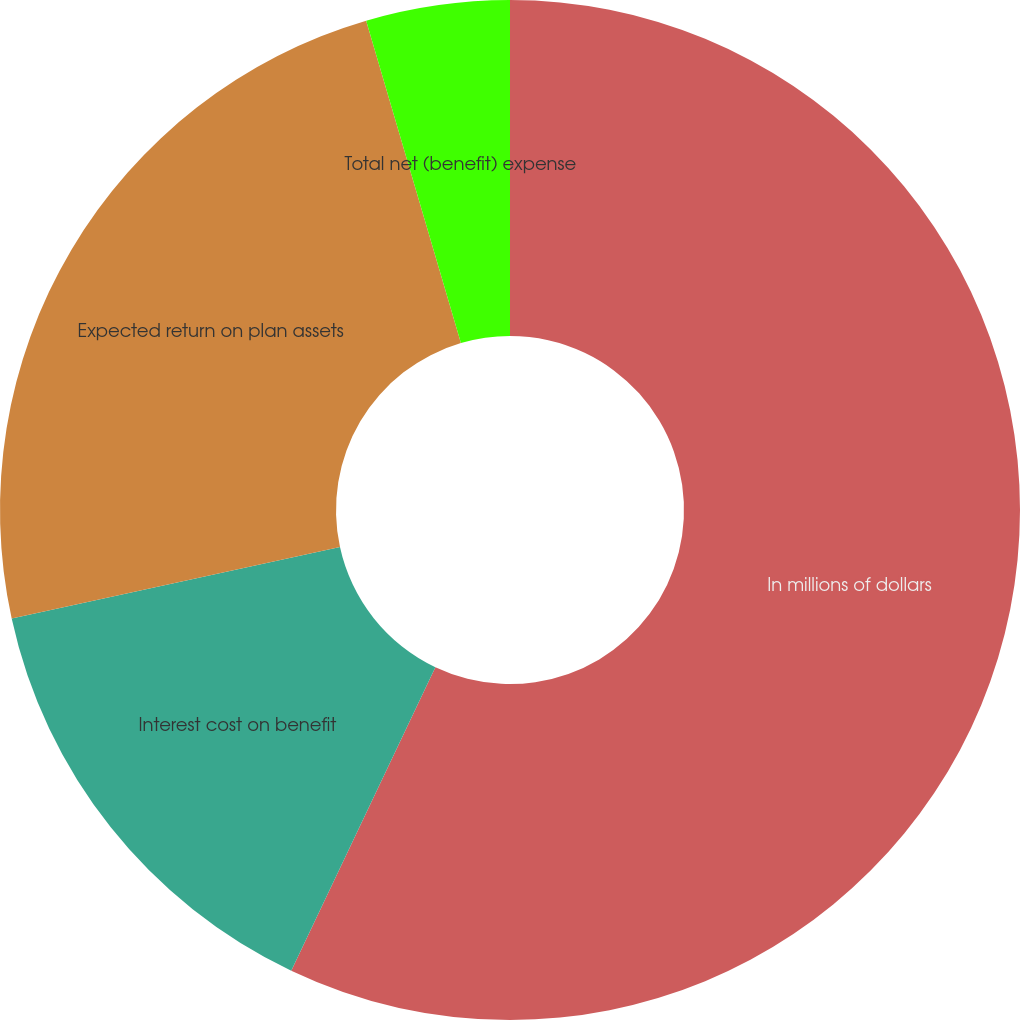Convert chart to OTSL. <chart><loc_0><loc_0><loc_500><loc_500><pie_chart><fcel>In millions of dollars<fcel>Interest cost on benefit<fcel>Expected return on plan assets<fcel>Total net (benefit) expense<nl><fcel>57.05%<fcel>14.53%<fcel>23.86%<fcel>4.55%<nl></chart> 